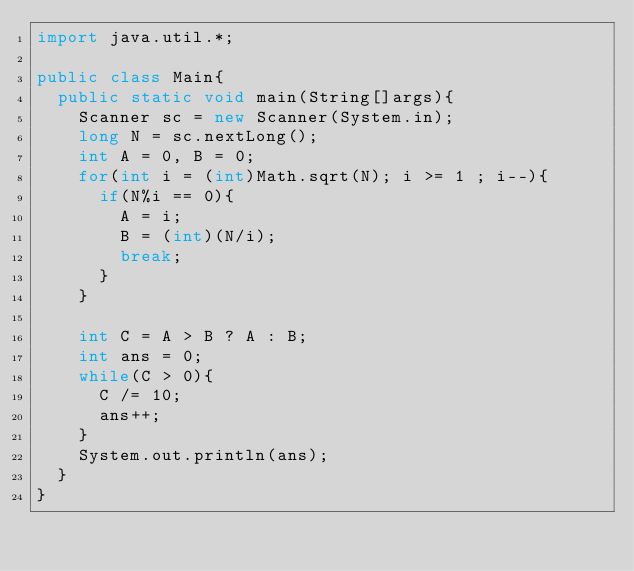<code> <loc_0><loc_0><loc_500><loc_500><_Java_>import java.util.*;

public class Main{
  public static void main(String[]args){
    Scanner sc = new Scanner(System.in);
    long N = sc.nextLong();
    int A = 0, B = 0;
    for(int i = (int)Math.sqrt(N); i >= 1 ; i--){
      if(N%i == 0){
        A = i;
        B = (int)(N/i);
        break;
      }
    }
    
    int C = A > B ? A : B;
    int ans = 0;
    while(C > 0){
      C /= 10;
      ans++;
    }
    System.out.println(ans);
  }
}
</code> 